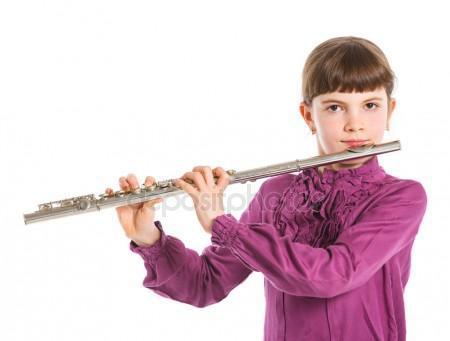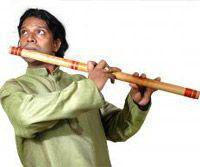The first image is the image on the left, the second image is the image on the right. Analyze the images presented: Is the assertion "One image shows one female playing a straight wind instrument, and the other image shows one male in green sleeves playing a wooden wind instrument." valid? Answer yes or no. Yes. The first image is the image on the left, the second image is the image on the right. Analyze the images presented: Is the assertion "At least one of the people is wearing a green shirt." valid? Answer yes or no. Yes. 